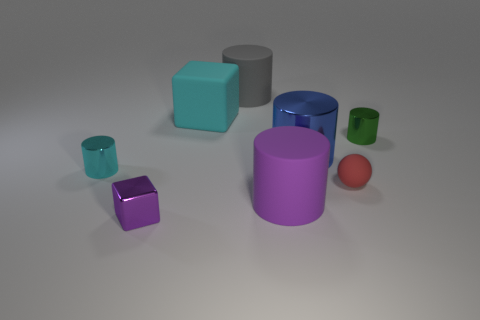Subtract all tiny green metal cylinders. How many cylinders are left? 4 Subtract all cyan cylinders. How many cylinders are left? 4 Add 1 big shiny cylinders. How many objects exist? 9 Subtract 1 cubes. How many cubes are left? 1 Add 1 gray matte cylinders. How many gray matte cylinders are left? 2 Add 5 big red matte cylinders. How many big red matte cylinders exist? 5 Subtract 0 brown cubes. How many objects are left? 8 Subtract all cylinders. How many objects are left? 3 Subtract all brown cylinders. Subtract all red balls. How many cylinders are left? 5 Subtract all blue cubes. How many blue cylinders are left? 1 